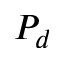Convert formula to latex. <formula><loc_0><loc_0><loc_500><loc_500>P _ { d }</formula> 